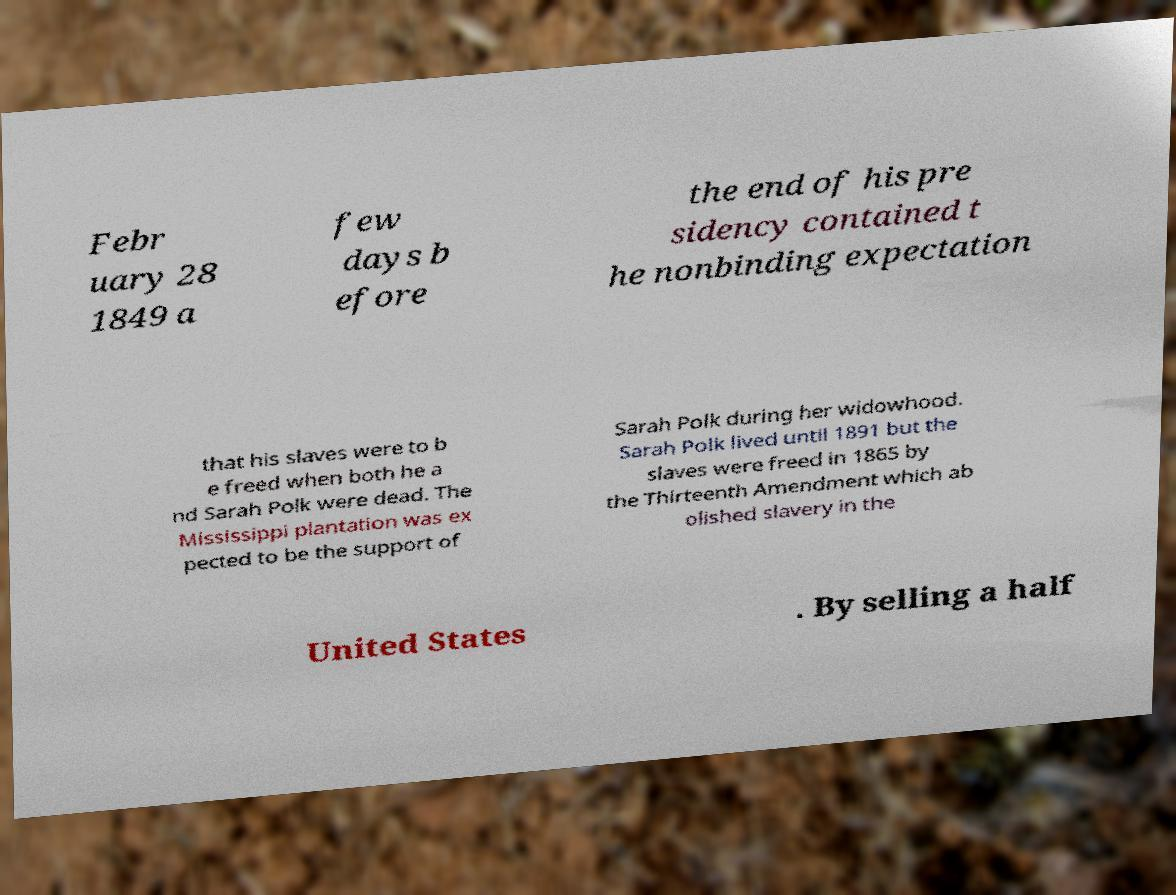What messages or text are displayed in this image? I need them in a readable, typed format. Febr uary 28 1849 a few days b efore the end of his pre sidency contained t he nonbinding expectation that his slaves were to b e freed when both he a nd Sarah Polk were dead. The Mississippi plantation was ex pected to be the support of Sarah Polk during her widowhood. Sarah Polk lived until 1891 but the slaves were freed in 1865 by the Thirteenth Amendment which ab olished slavery in the United States . By selling a half 